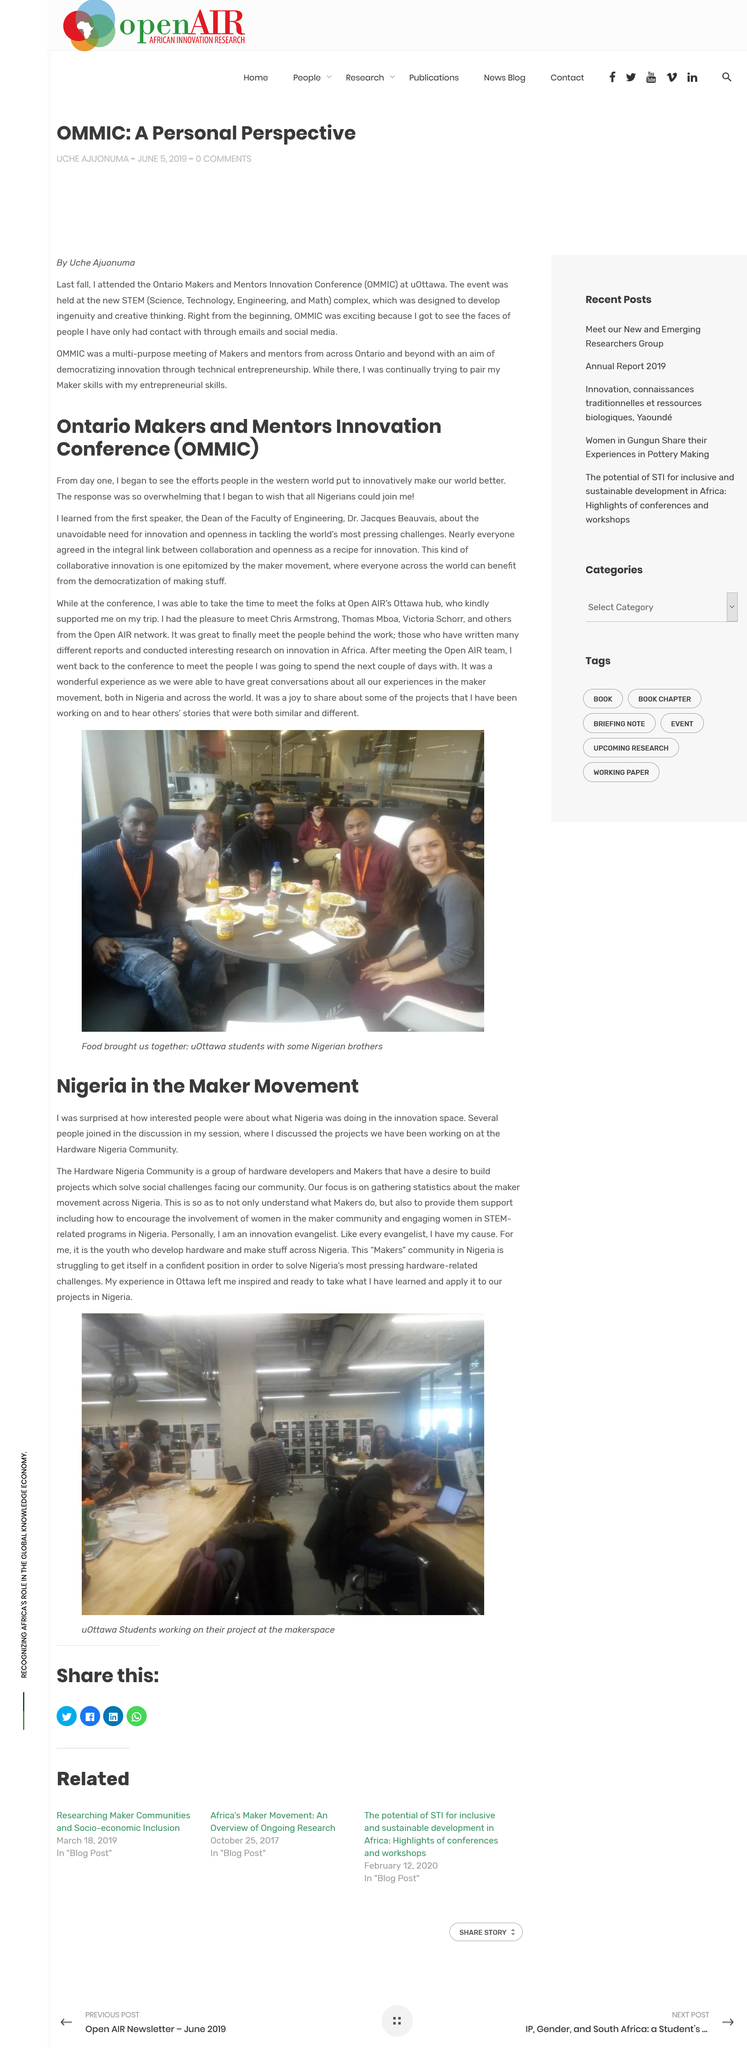Outline some significant characteristics in this image. The OMMIC acronym stands for "Ontario Makers and Mentors Innovation Conference," which is a gathering of individuals and organizations from the province of Ontario who are dedicated to promoting innovation and collaboration in the field of technology and entrepreneurship. The first speaker at OMMIC was Dr. Jacques Beauvais, the Dean of the Faculty of Engineering. The first speaker discussed the inevitability of innovation and openness in addressing the most significant global concerns. 